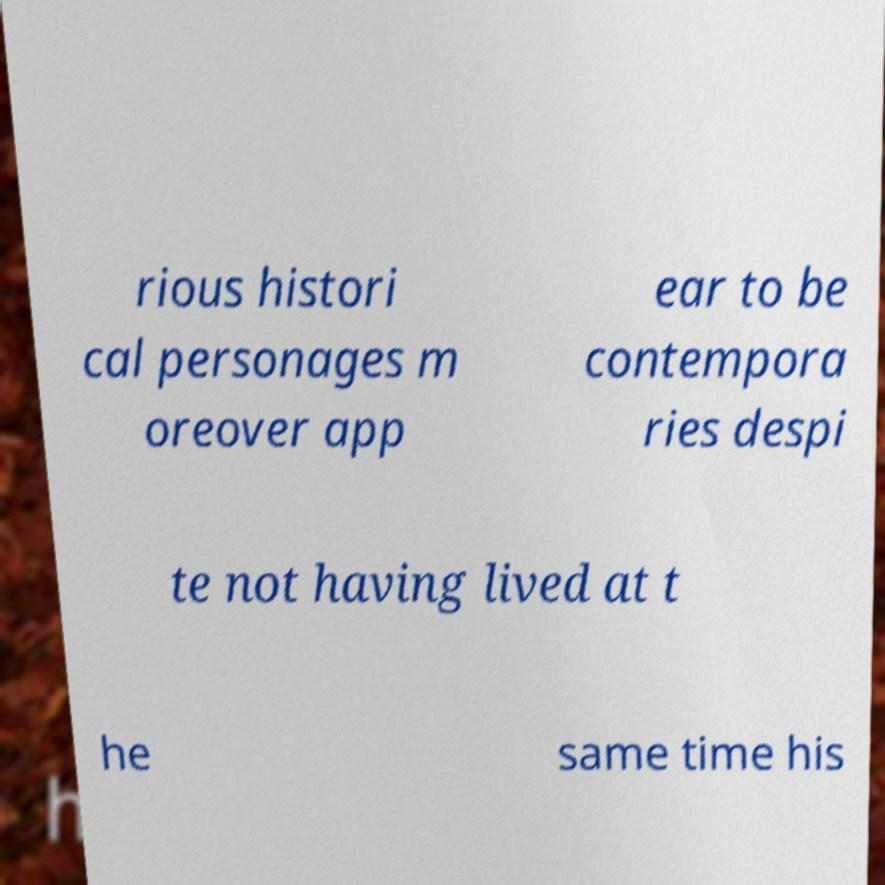Please identify and transcribe the text found in this image. rious histori cal personages m oreover app ear to be contempora ries despi te not having lived at t he same time his 